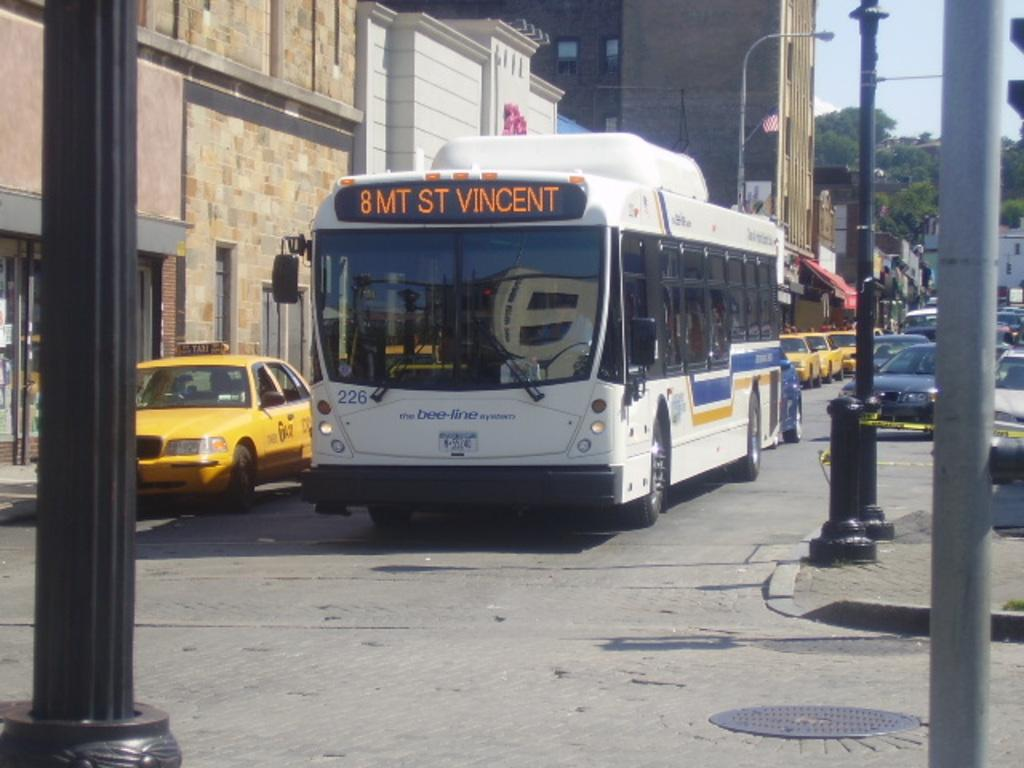<image>
Write a terse but informative summary of the picture. The bus is going to St. Vincent now 